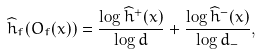<formula> <loc_0><loc_0><loc_500><loc_500>\widehat { h } _ { f } ( O _ { f } ( x ) ) = \frac { \log \widehat { h } ^ { + } ( x ) } { \log d } + \frac { \log \widehat { h } ^ { - } ( x ) } { \log d _ { - } } ,</formula> 